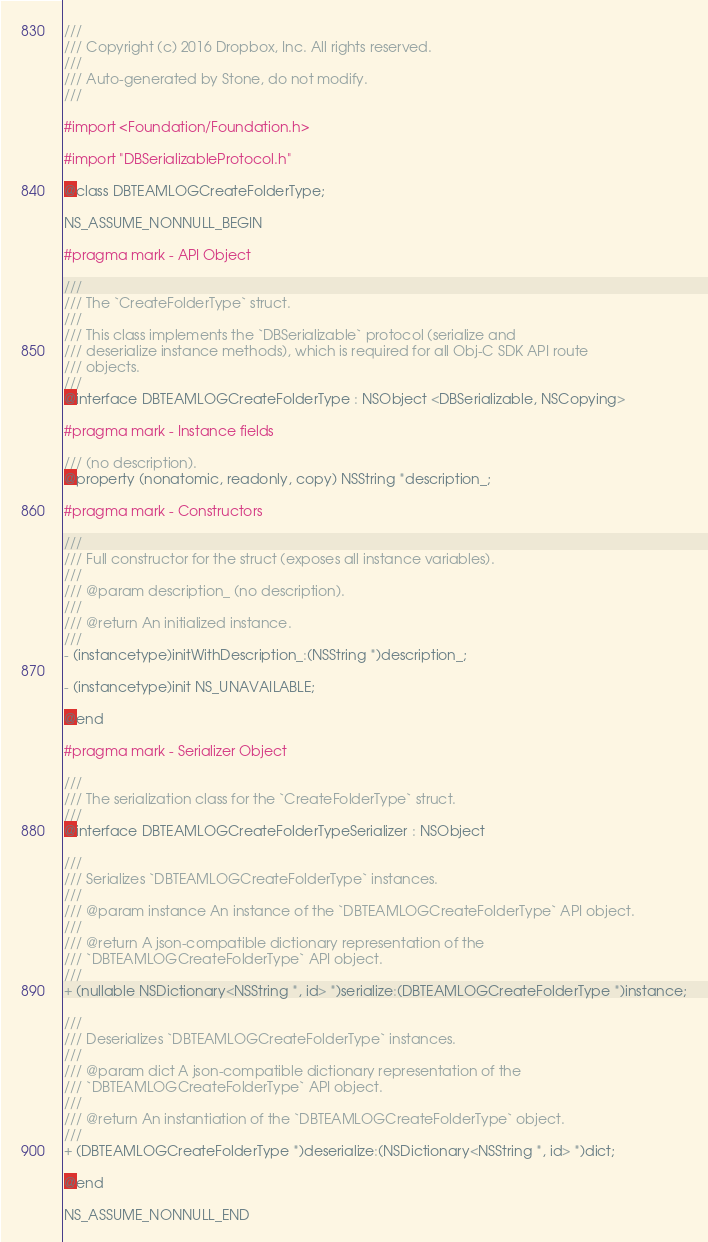<code> <loc_0><loc_0><loc_500><loc_500><_C_>///
/// Copyright (c) 2016 Dropbox, Inc. All rights reserved.
///
/// Auto-generated by Stone, do not modify.
///

#import <Foundation/Foundation.h>

#import "DBSerializableProtocol.h"

@class DBTEAMLOGCreateFolderType;

NS_ASSUME_NONNULL_BEGIN

#pragma mark - API Object

///
/// The `CreateFolderType` struct.
///
/// This class implements the `DBSerializable` protocol (serialize and
/// deserialize instance methods), which is required for all Obj-C SDK API route
/// objects.
///
@interface DBTEAMLOGCreateFolderType : NSObject <DBSerializable, NSCopying>

#pragma mark - Instance fields

/// (no description).
@property (nonatomic, readonly, copy) NSString *description_;

#pragma mark - Constructors

///
/// Full constructor for the struct (exposes all instance variables).
///
/// @param description_ (no description).
///
/// @return An initialized instance.
///
- (instancetype)initWithDescription_:(NSString *)description_;

- (instancetype)init NS_UNAVAILABLE;

@end

#pragma mark - Serializer Object

///
/// The serialization class for the `CreateFolderType` struct.
///
@interface DBTEAMLOGCreateFolderTypeSerializer : NSObject

///
/// Serializes `DBTEAMLOGCreateFolderType` instances.
///
/// @param instance An instance of the `DBTEAMLOGCreateFolderType` API object.
///
/// @return A json-compatible dictionary representation of the
/// `DBTEAMLOGCreateFolderType` API object.
///
+ (nullable NSDictionary<NSString *, id> *)serialize:(DBTEAMLOGCreateFolderType *)instance;

///
/// Deserializes `DBTEAMLOGCreateFolderType` instances.
///
/// @param dict A json-compatible dictionary representation of the
/// `DBTEAMLOGCreateFolderType` API object.
///
/// @return An instantiation of the `DBTEAMLOGCreateFolderType` object.
///
+ (DBTEAMLOGCreateFolderType *)deserialize:(NSDictionary<NSString *, id> *)dict;

@end

NS_ASSUME_NONNULL_END
</code> 